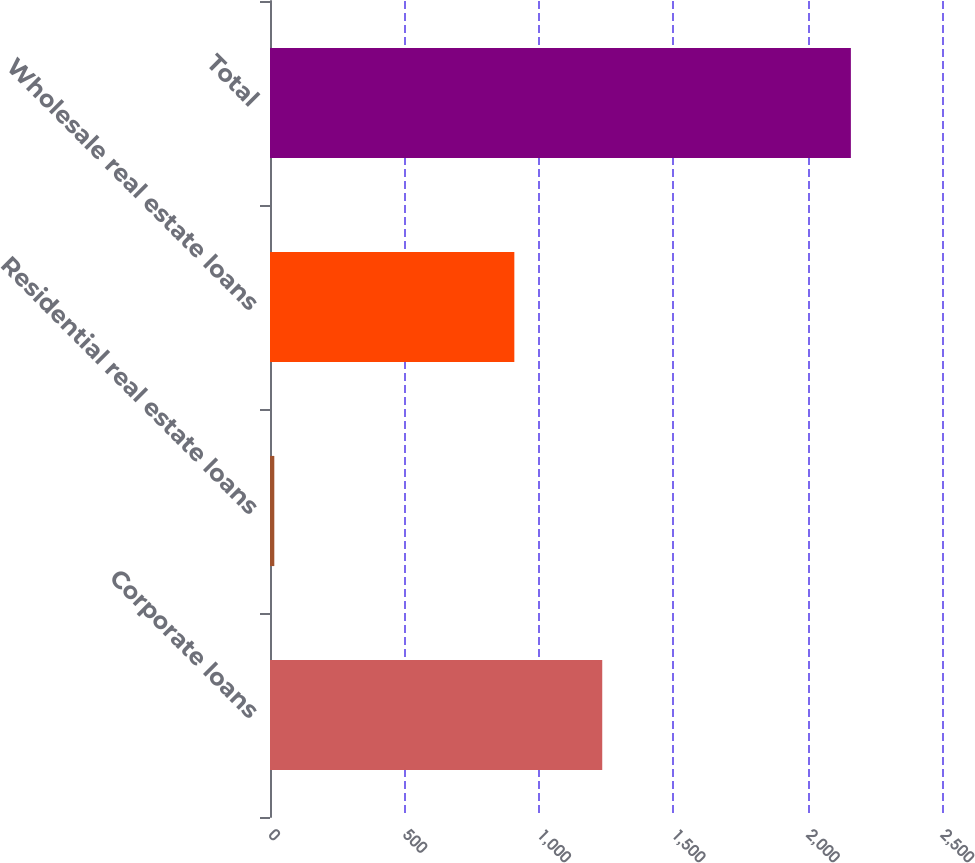Convert chart to OTSL. <chart><loc_0><loc_0><loc_500><loc_500><bar_chart><fcel>Corporate loans<fcel>Residential real estate loans<fcel>Wholesale real estate loans<fcel>Total<nl><fcel>1236<fcel>16<fcel>909<fcel>2161<nl></chart> 